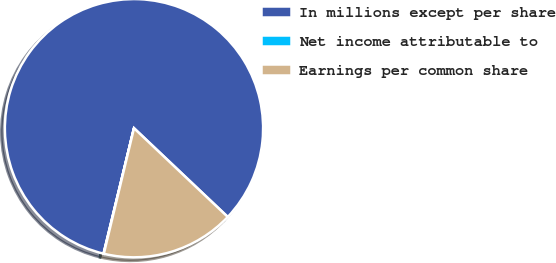<chart> <loc_0><loc_0><loc_500><loc_500><pie_chart><fcel>In millions except per share<fcel>Net income attributable to<fcel>Earnings per common share<nl><fcel>83.27%<fcel>0.04%<fcel>16.69%<nl></chart> 